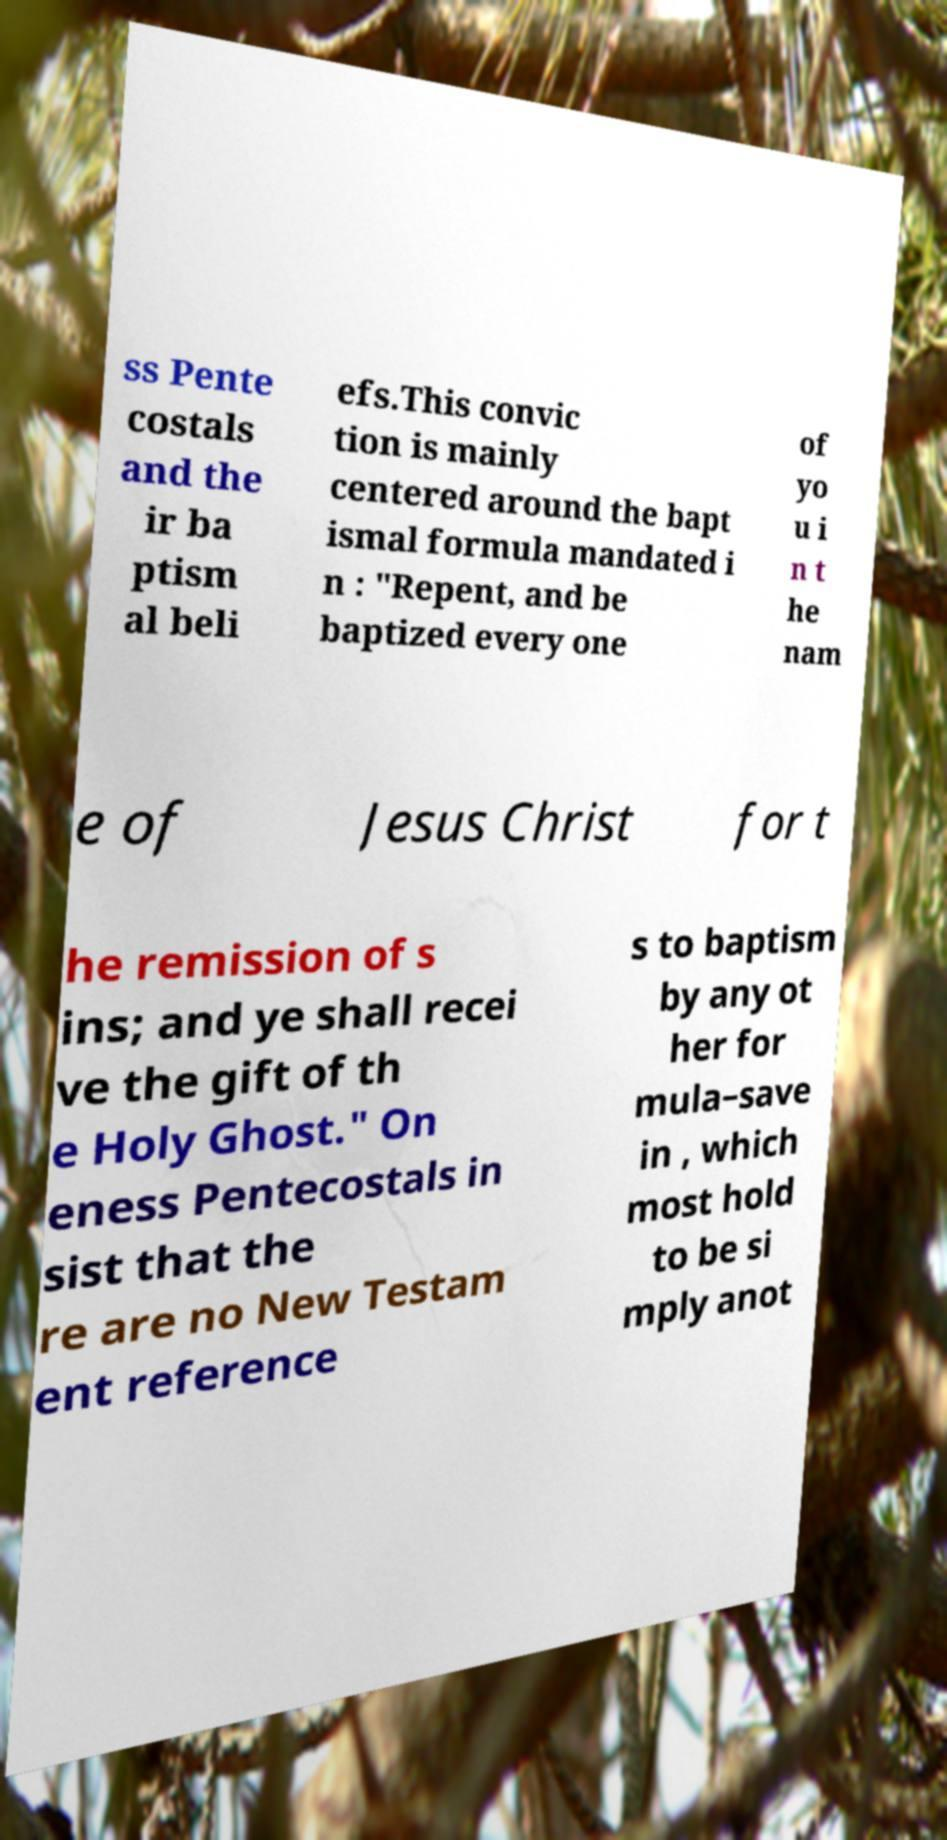Please read and relay the text visible in this image. What does it say? ss Pente costals and the ir ba ptism al beli efs.This convic tion is mainly centered around the bapt ismal formula mandated i n : "Repent, and be baptized every one of yo u i n t he nam e of Jesus Christ for t he remission of s ins; and ye shall recei ve the gift of th e Holy Ghost." On eness Pentecostals in sist that the re are no New Testam ent reference s to baptism by any ot her for mula–save in , which most hold to be si mply anot 